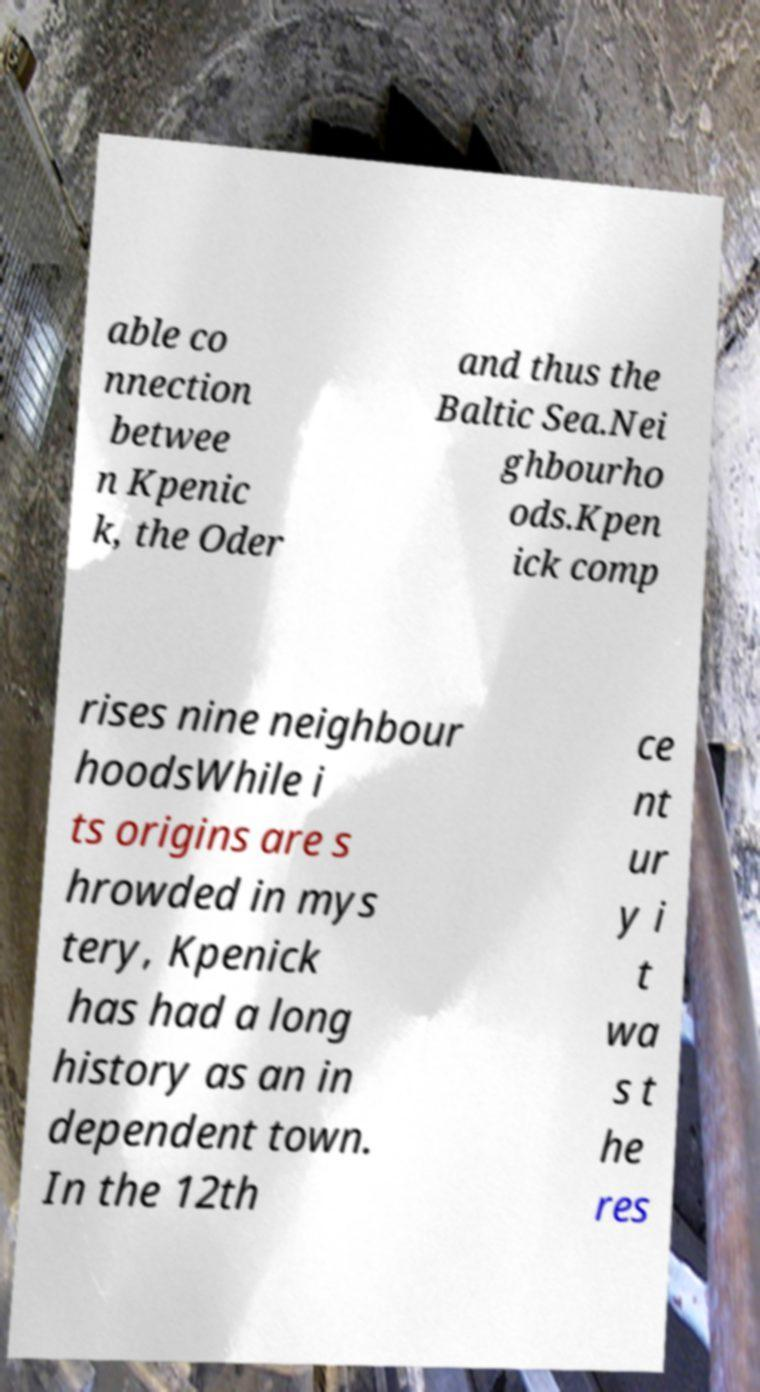There's text embedded in this image that I need extracted. Can you transcribe it verbatim? able co nnection betwee n Kpenic k, the Oder and thus the Baltic Sea.Nei ghbourho ods.Kpen ick comp rises nine neighbour hoodsWhile i ts origins are s hrowded in mys tery, Kpenick has had a long history as an in dependent town. In the 12th ce nt ur y i t wa s t he res 